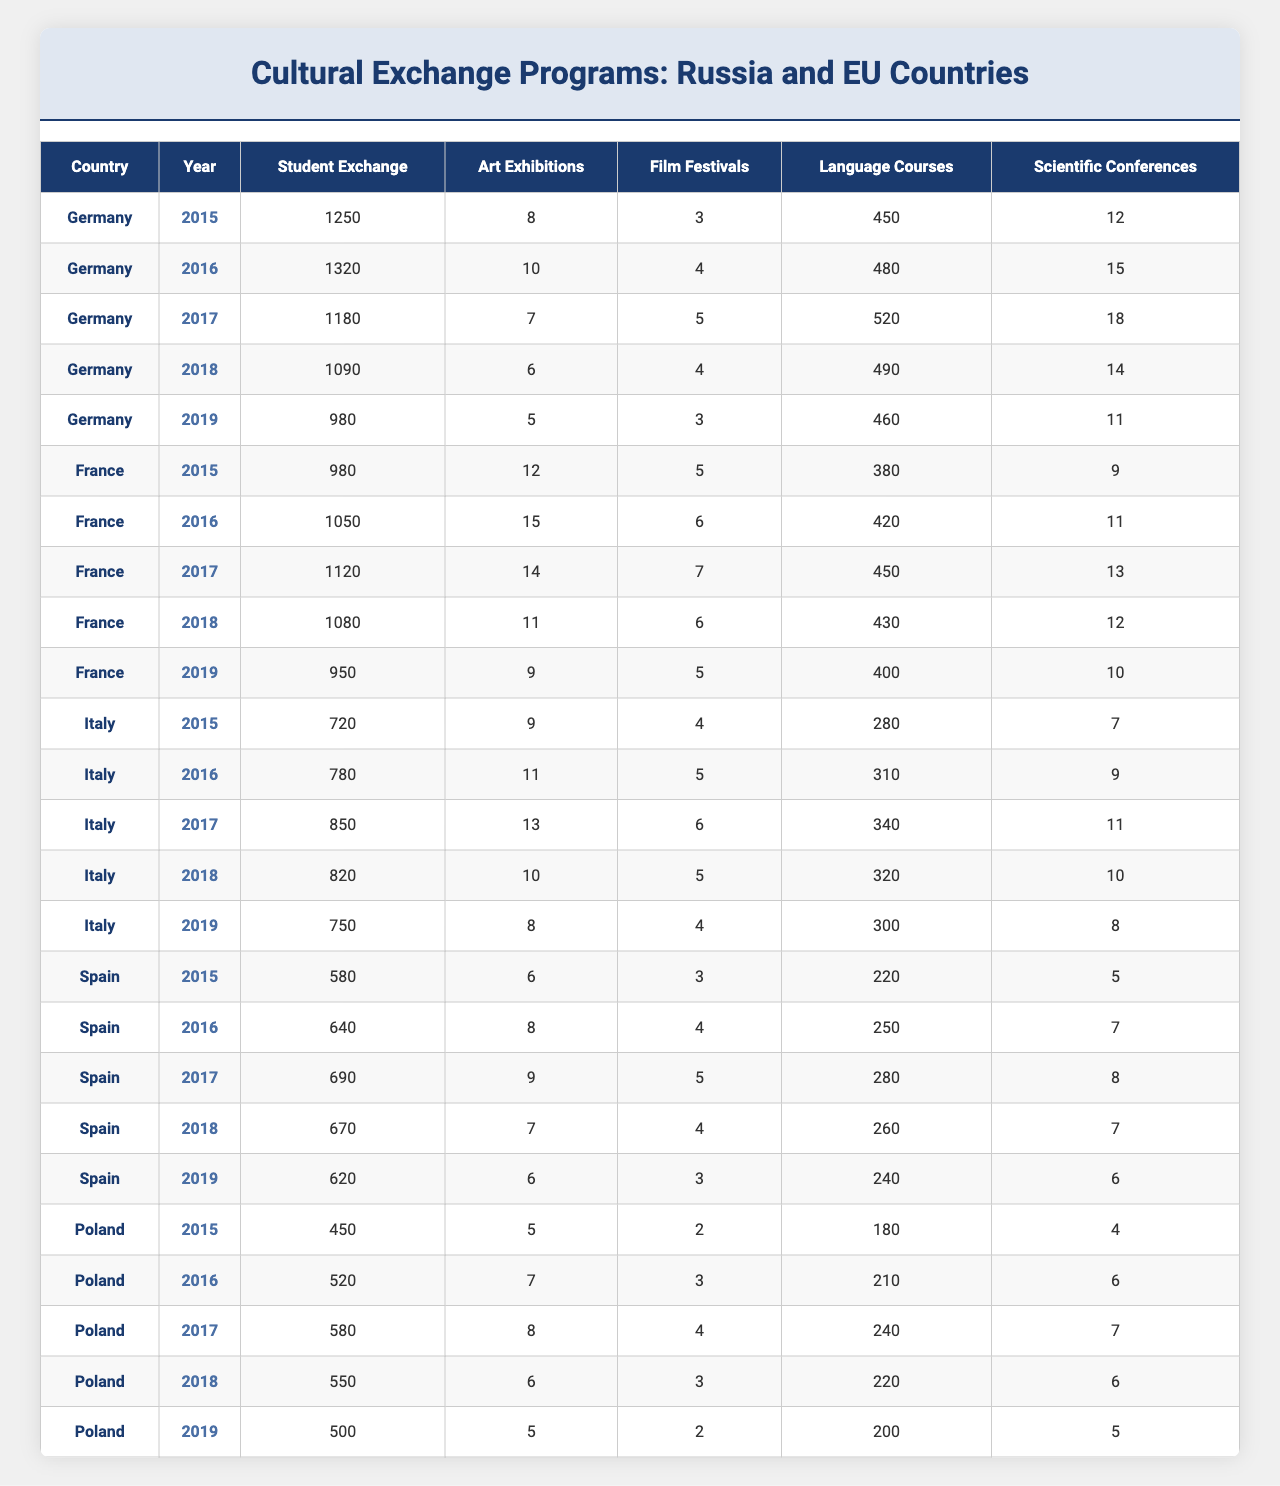What was the highest number of student exchanges between Russia and Germany in a single year? Referring to the table, the year with the highest student exchange between Russia and Germany is 2016, which had 1,320 exchanges.
Answer: 1320 Which country received the fewest student exchanges in 2019? In 2019, the student exchanges were: Germany (980), France (950), Italy (750), Spain (620), and Poland (500). Poland had the fewest exchanges at 500.
Answer: Poland What is the total number of art exhibitions held in France between 2015 and 2019? Summing the art exhibitions in France from 2015 to 2019: (12 + 15 + 14 + 11 + 9) = 61.
Answer: 61 In which year did Italy have the highest number of film festivals? The film festivals in Italy from 2015 to 2019 were: 4 (2015), 5 (2016), 6 (2017), 5 (2018), 4 (2019). The highest was in 2017 with 6 festivals.
Answer: 2017 Was there a decrease in the number of language courses in Poland from 2017 to 2019? Looking at the language courses in Poland for those years: 240 (2017), 220 (2018), 200 (2019). There was a decrease each year, confirming a drop from 240 to 200.
Answer: Yes What was the average number of scientific conferences held across all countries in 2016? The total conferences in 2016 are: Germany (15), France (11), Italy (9), Spain (7), and Poland (6), totaling 48 conferences. The average is 48/5 = 9.6.
Answer: 9.6 How many more student exchanges were there in Germany compared to Spain in 2018? In 2018, Germany had 1,090 student exchanges and Spain had 670. The difference is 1,090 - 670 = 420.
Answer: 420 Which country had the highest number of language courses in 2017? Analyzing the data: Germany (520), France (450), Italy (340), Spain (280), and Poland (240). Germany had the highest at 520 courses.
Answer: Germany What trend can be observed in the number of film festivals in Spain from 2015 to 2019? The film festival figures from 2015 (3) to 2019 (3) show fluctuations: increasing to 4 in 2016, 5 in 2017, then back to 4 in 2018 and 3 in 2019. Overall, there wasn't a significant increase.
Answer: Fluctuating Did the number of art exhibitions in Italy exceed those in Poland in any year? Checking the art exhibition figures: Italy's highest was 13 in 2017, while Poland's highest was 8 in 2017. Italy exceeded Poland in that year.
Answer: Yes 